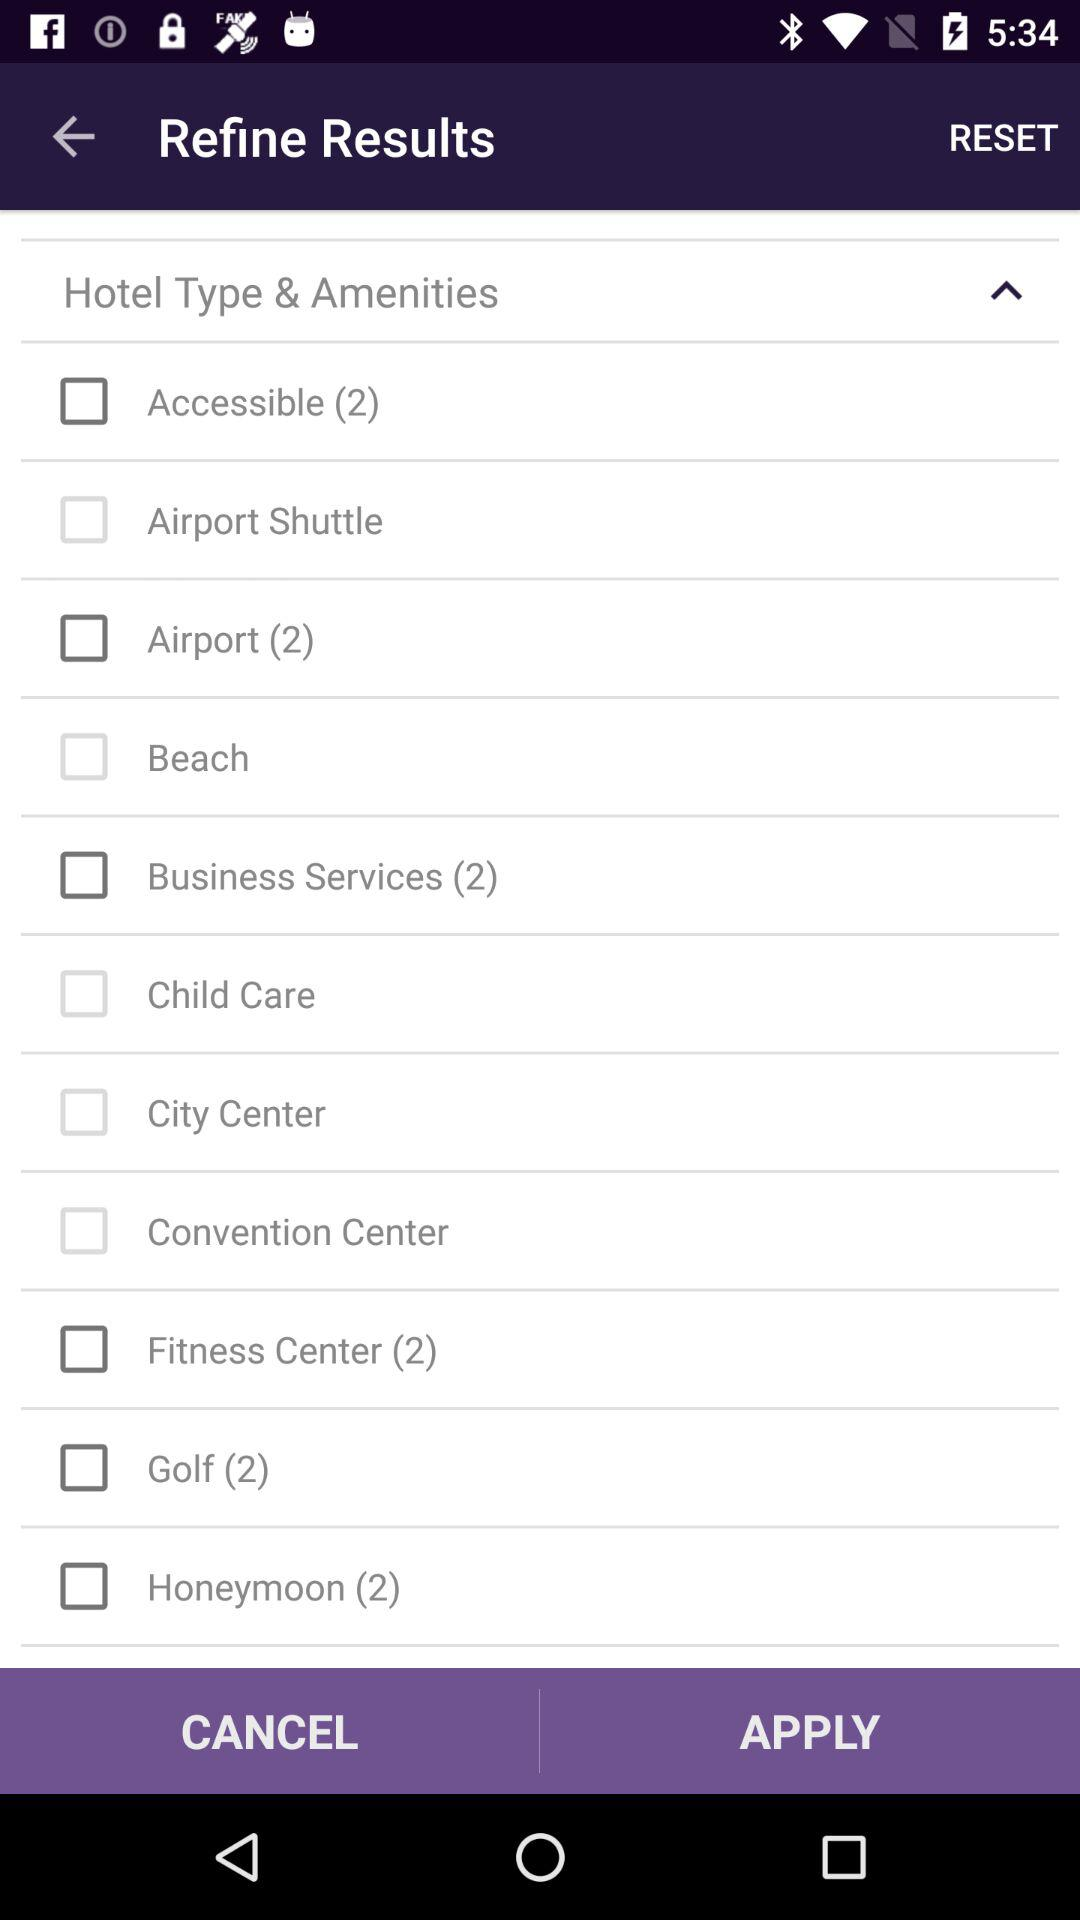Can you tell me a few names of "Hotel Type and Amenities"? The few names of hotel types and amenities are "Accessible (2)", "Airport Shuttle" and "Airport (2)". 